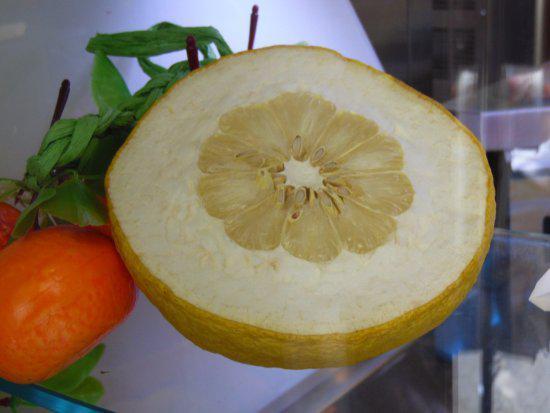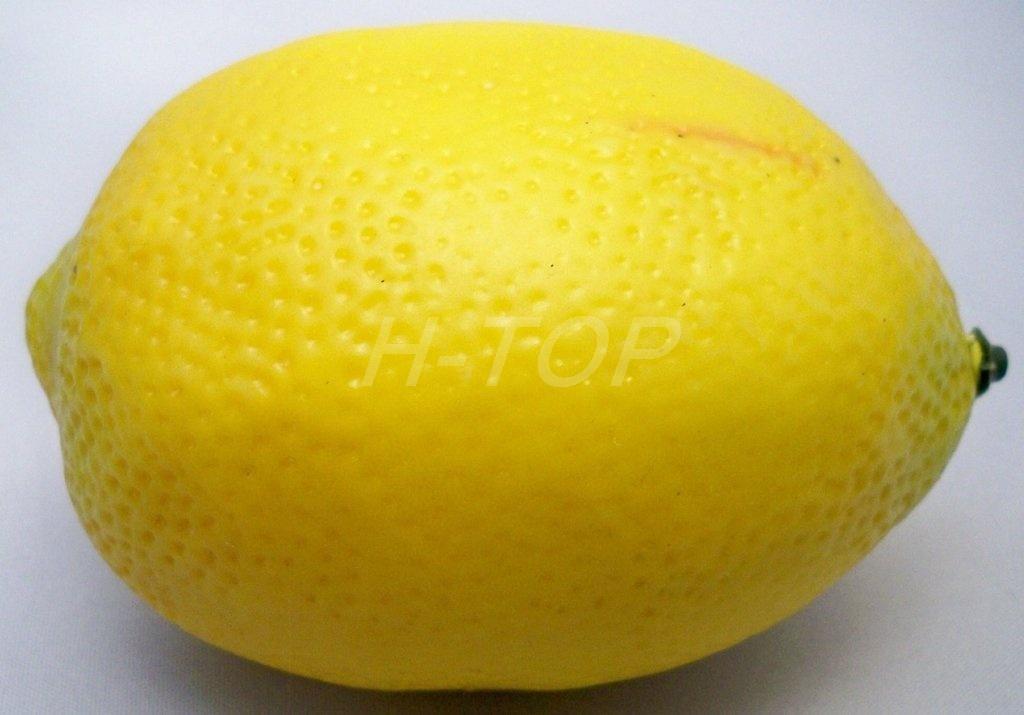The first image is the image on the left, the second image is the image on the right. For the images displayed, is the sentence "The right image includes yellow fruit in a round bowl, and the left image shows a small fruit on the left of a larger fruit of the same color." factually correct? Answer yes or no. No. The first image is the image on the left, the second image is the image on the right. Assess this claim about the two images: "The left image shows two fruit next to each other, one large and one small, while the right image shows at least three fruit in a bowl.". Correct or not? Answer yes or no. No. 